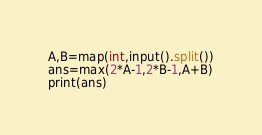Convert code to text. <code><loc_0><loc_0><loc_500><loc_500><_Java_>A,B=map(int,input().split())
ans=max(2*A-1,2*B-1,A+B)
print(ans)</code> 